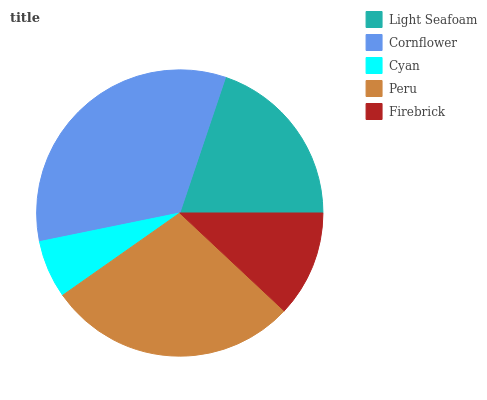Is Cyan the minimum?
Answer yes or no. Yes. Is Cornflower the maximum?
Answer yes or no. Yes. Is Cornflower the minimum?
Answer yes or no. No. Is Cyan the maximum?
Answer yes or no. No. Is Cornflower greater than Cyan?
Answer yes or no. Yes. Is Cyan less than Cornflower?
Answer yes or no. Yes. Is Cyan greater than Cornflower?
Answer yes or no. No. Is Cornflower less than Cyan?
Answer yes or no. No. Is Light Seafoam the high median?
Answer yes or no. Yes. Is Light Seafoam the low median?
Answer yes or no. Yes. Is Firebrick the high median?
Answer yes or no. No. Is Peru the low median?
Answer yes or no. No. 